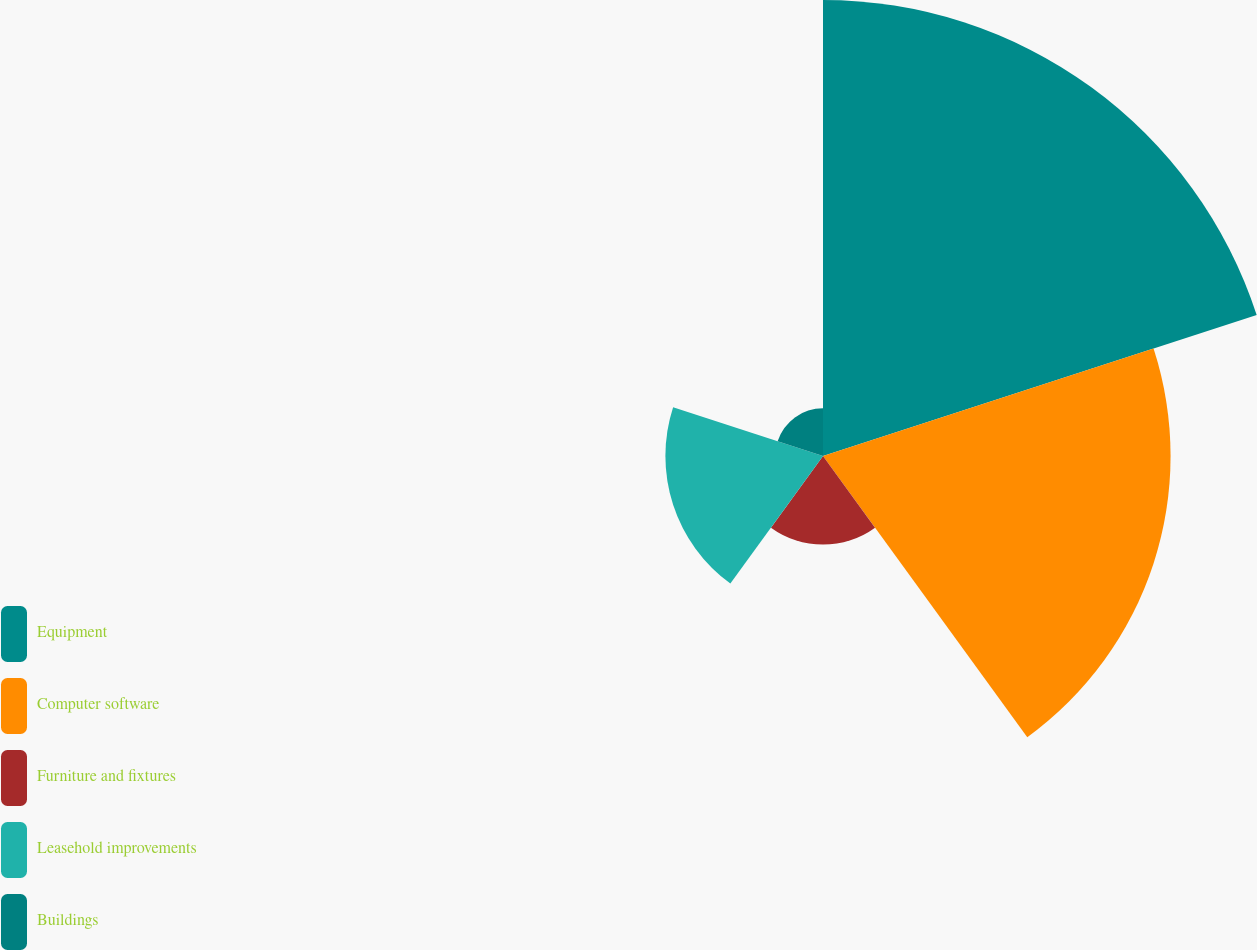Convert chart to OTSL. <chart><loc_0><loc_0><loc_500><loc_500><pie_chart><fcel>Equipment<fcel>Computer software<fcel>Furniture and fixtures<fcel>Leasehold improvements<fcel>Buildings<nl><fcel>41.55%<fcel>31.67%<fcel>8.07%<fcel>14.36%<fcel>4.35%<nl></chart> 